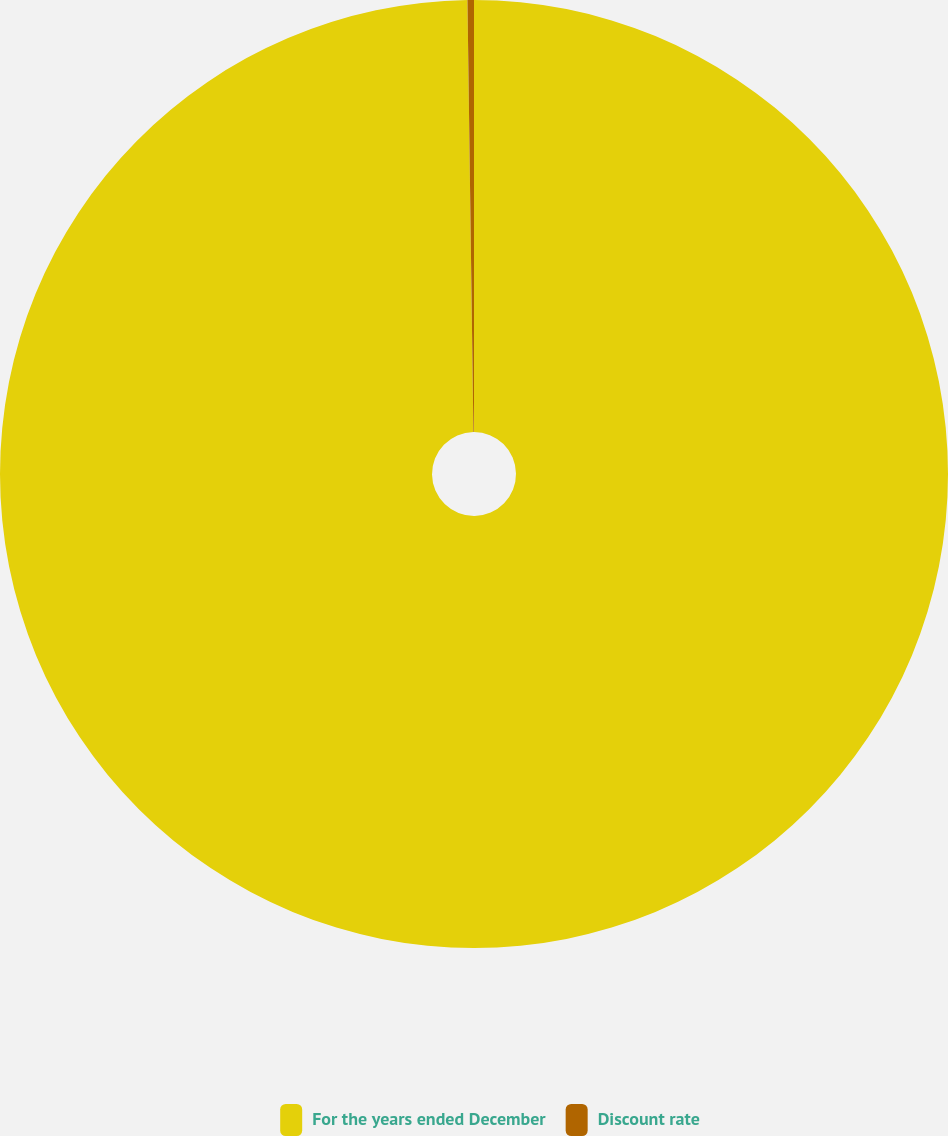<chart> <loc_0><loc_0><loc_500><loc_500><pie_chart><fcel>For the years ended December<fcel>Discount rate<nl><fcel>99.78%<fcel>0.22%<nl></chart> 